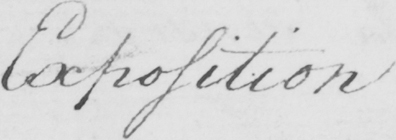Transcribe the text shown in this historical manuscript line. Exposition 